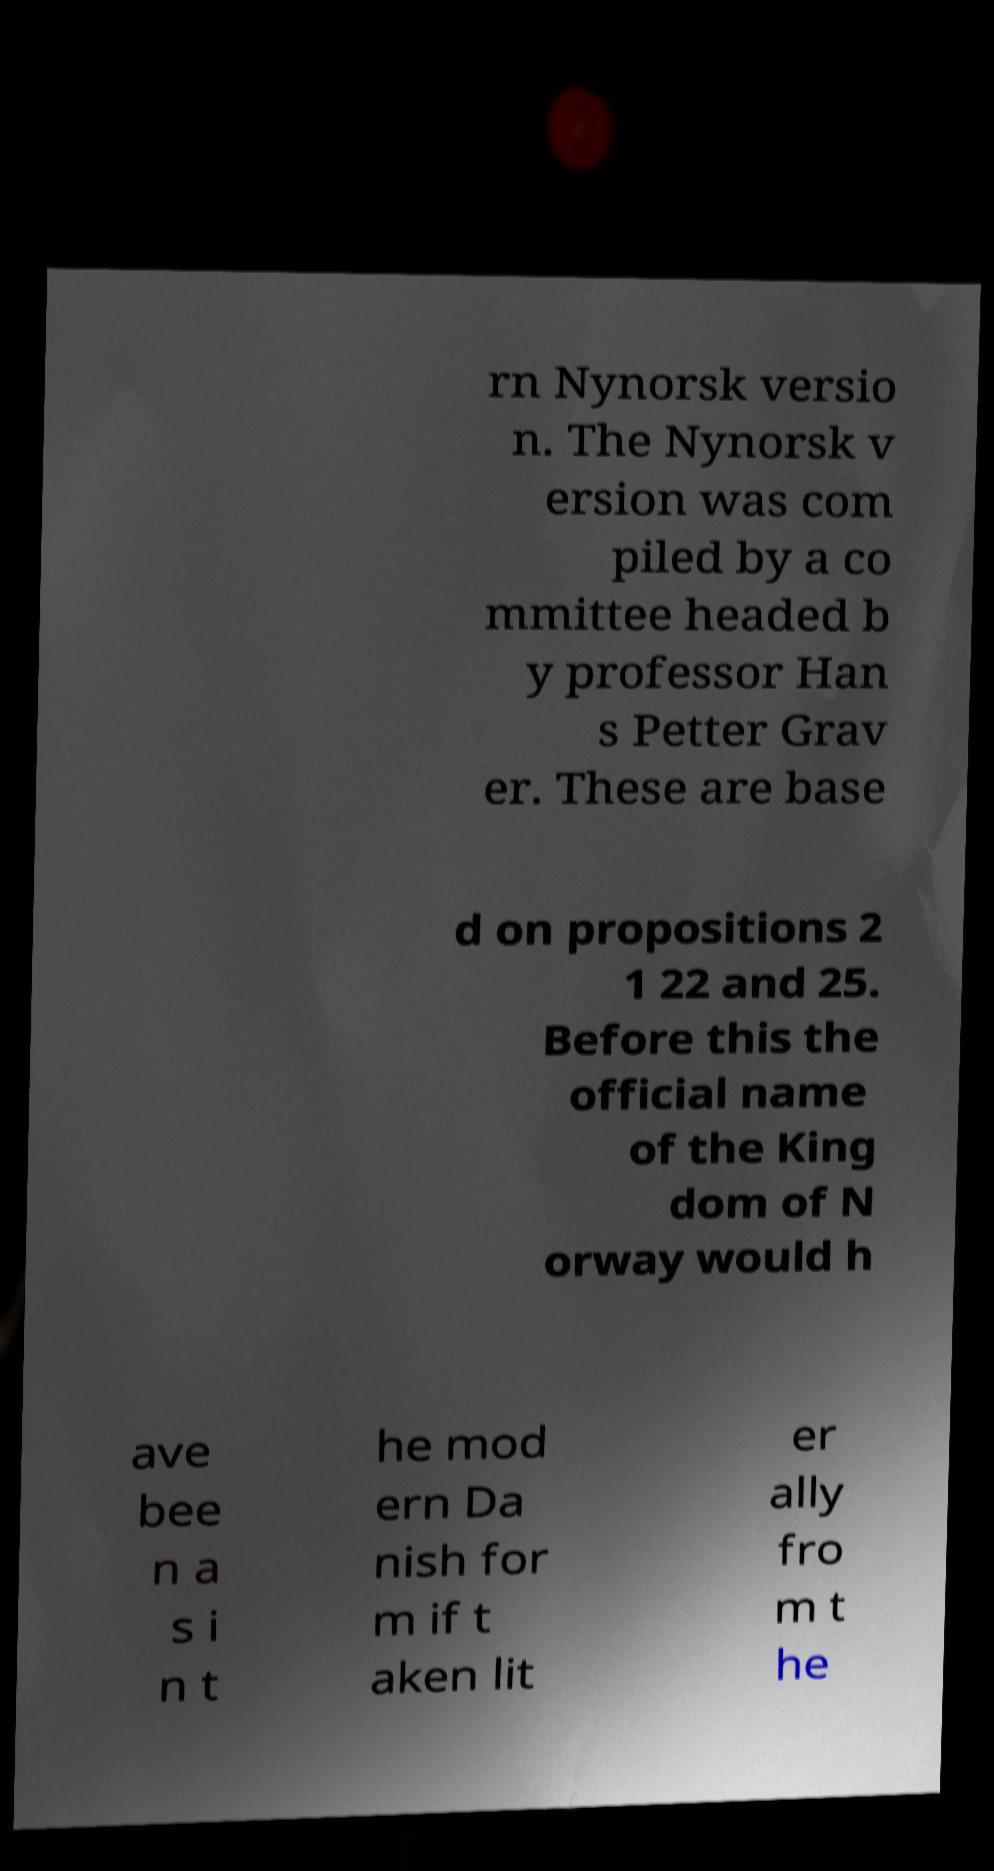What messages or text are displayed in this image? I need them in a readable, typed format. rn Nynorsk versio n. The Nynorsk v ersion was com piled by a co mmittee headed b y professor Han s Petter Grav er. These are base d on propositions 2 1 22 and 25. Before this the official name of the King dom of N orway would h ave bee n a s i n t he mod ern Da nish for m if t aken lit er ally fro m t he 